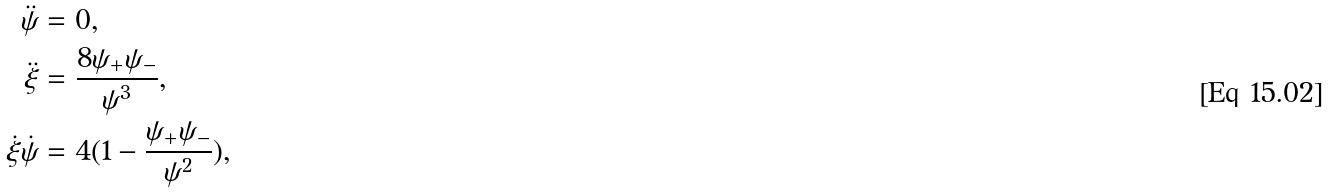Convert formula to latex. <formula><loc_0><loc_0><loc_500><loc_500>\ddot { \psi } & = 0 , \\ \ddot { \xi } & = \frac { 8 \psi _ { + } \psi _ { - } } { \psi ^ { 3 } } , \\ \dot { \xi } \dot { \psi } & = 4 ( 1 - \frac { \psi _ { + } \psi _ { - } } { \psi ^ { 2 } } ) ,</formula> 